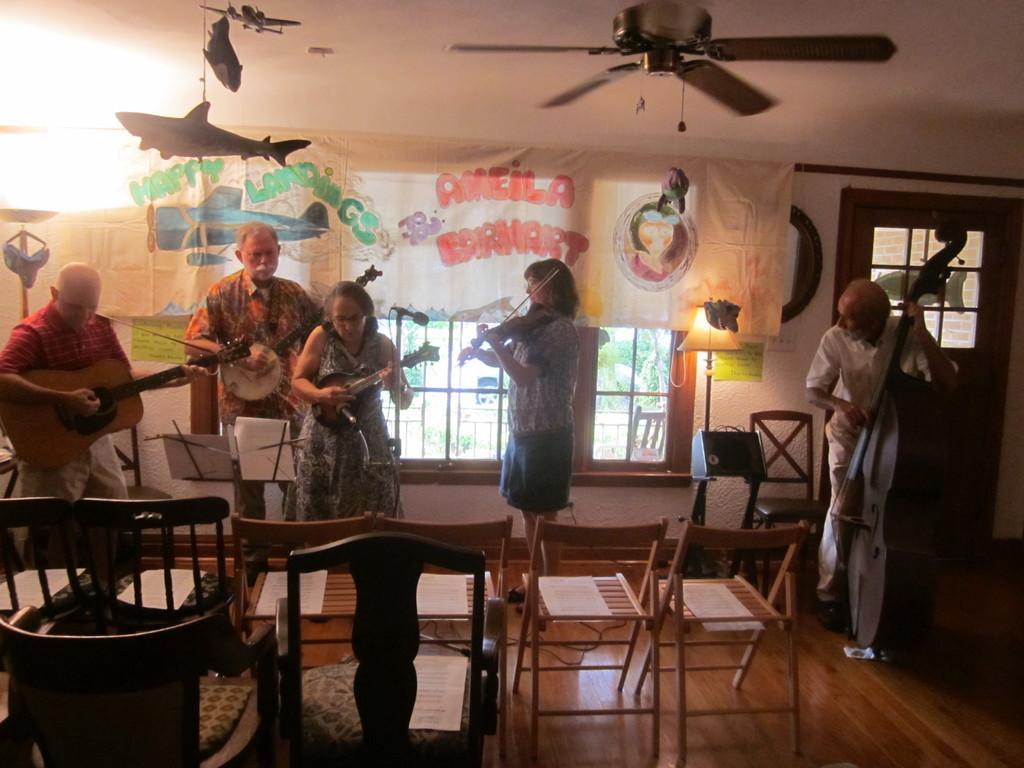Please provide a concise description of this image. In the picture I can see a group of people are standing and playing musical instruments. I can also see chairs, windows, a door, a light lamp, a fan and some other things attached to the ceiling. This is an inside view of a room. 